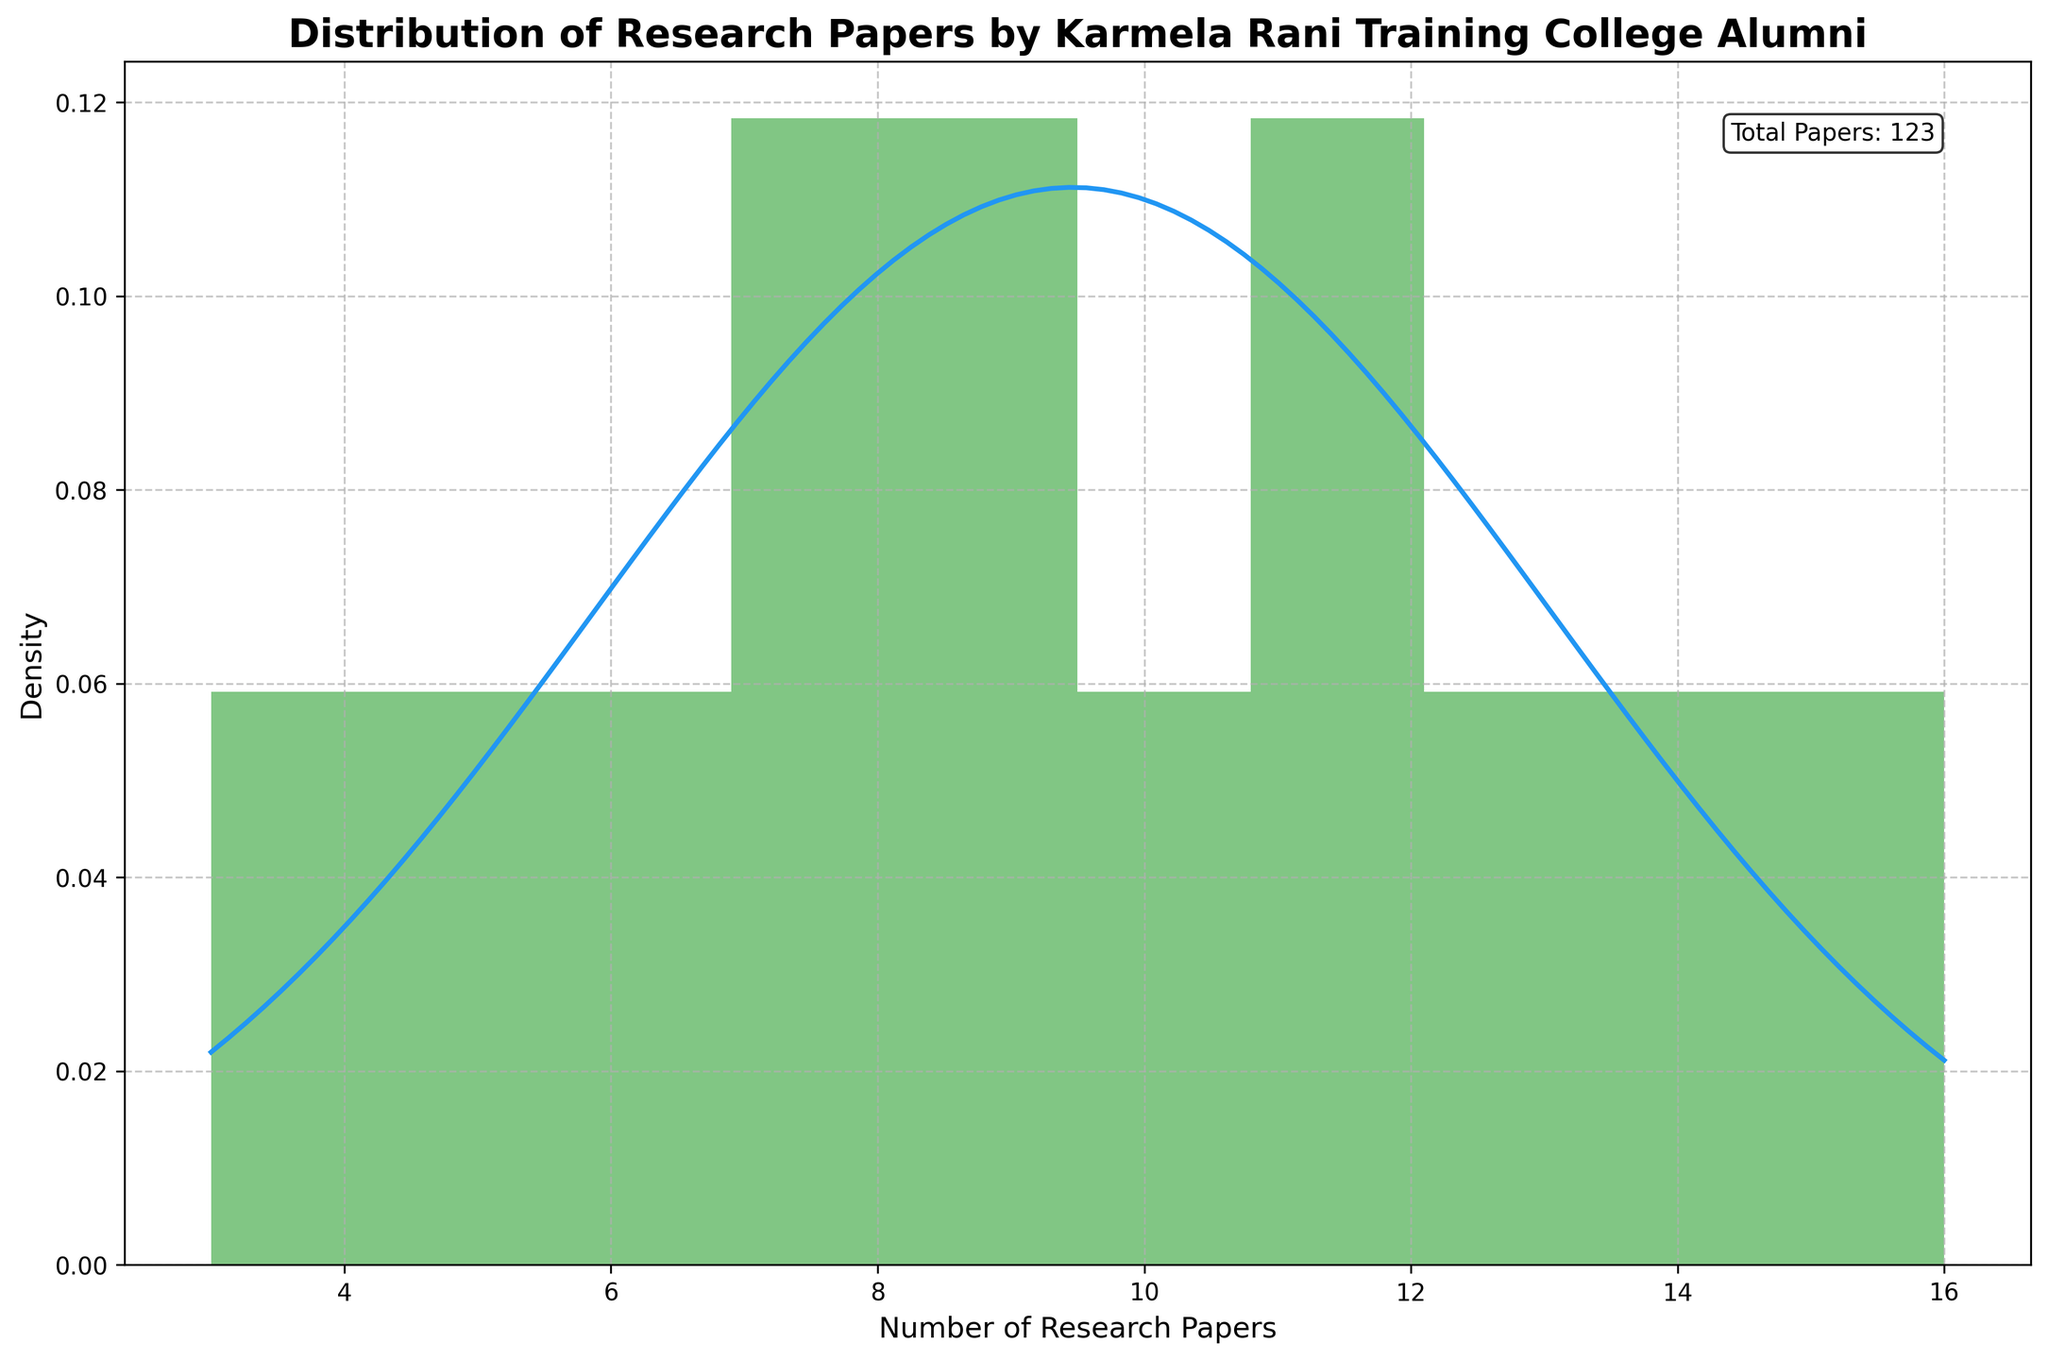What is the title of the plot? Locate the title at the top of the figure. The title is clearly labeled.
Answer: Distribution of Research Papers by Karmela Rani Training College Alumni How many research papers were published in 2020? Refer to the highest point of the curve for the year 2020, showing the count of papers.
Answer: 14 What is the color of the histogram bars in the plot? Identify the color of the bars visually in the figure.
Answer: Green Which year had the highest number of research papers published? Identify the peak year in the data associated with the maximum number of research papers, often shown as an annotation or visible in the curve peaks.
Answer: 2021 How many years are covered in the distribution? Count the number of distinct years marked on the x-axis or mentioned in the data range.
Answer: 13 What is the maximum value of research papers published in a single year? Look at the highest mark on the x-axis indicating the maximum value on the distribution.
Answer: 16 What is the average number of research papers published per year? Sum all values of research papers and divide by the number of years displayed. Calculate (5+3+7+9+6+8+12+10+11+9+14+16+13) / 13.
Answer: 9.77 Compare the number of research papers published in 2015 and 2018. Which year had more publications? Check and compare the count of papers for the years 2015 and 2018 as indicated on the histogram.
Answer: 2018 What is the most common range of research papers published per year? Identify the range segment in the histogram where most bars are concentrated, typically where the bars are tallest or most frequent.
Answer: 8-12 Is there a trend in the number of research papers published over the years? Observe the trend by following the general direction (increase, decrease, or no change) indicated by the histogram or annotated data points over the years.
Answer: Increasing trend 